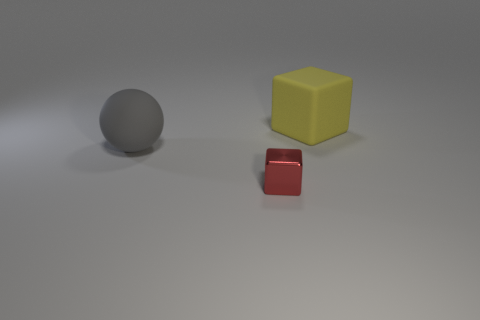Add 2 brown rubber cubes. How many objects exist? 5 Subtract all spheres. How many objects are left? 2 Subtract all big brown metal objects. Subtract all big rubber objects. How many objects are left? 1 Add 2 red cubes. How many red cubes are left? 3 Add 2 purple rubber cylinders. How many purple rubber cylinders exist? 2 Subtract 0 blue spheres. How many objects are left? 3 